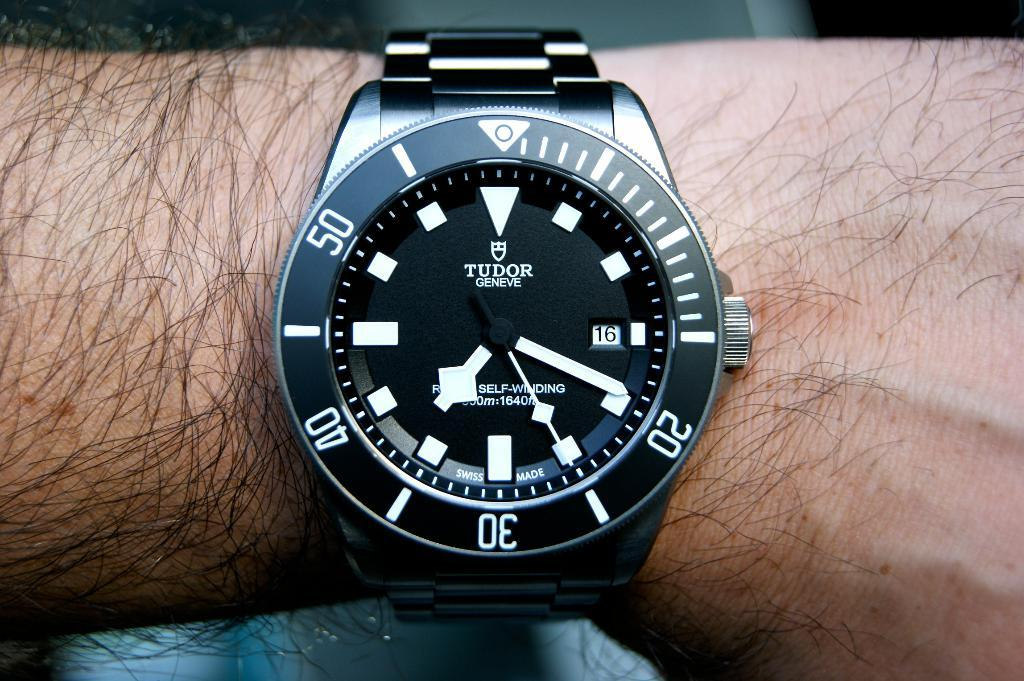<image>
Write a terse but informative summary of the picture. Person wearing a black and white wristwatch which says TUDOR on it. 